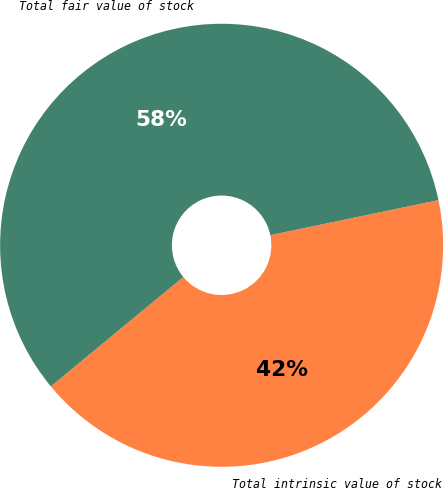Convert chart to OTSL. <chart><loc_0><loc_0><loc_500><loc_500><pie_chart><fcel>Total intrinsic value of stock<fcel>Total fair value of stock<nl><fcel>42.28%<fcel>57.72%<nl></chart> 